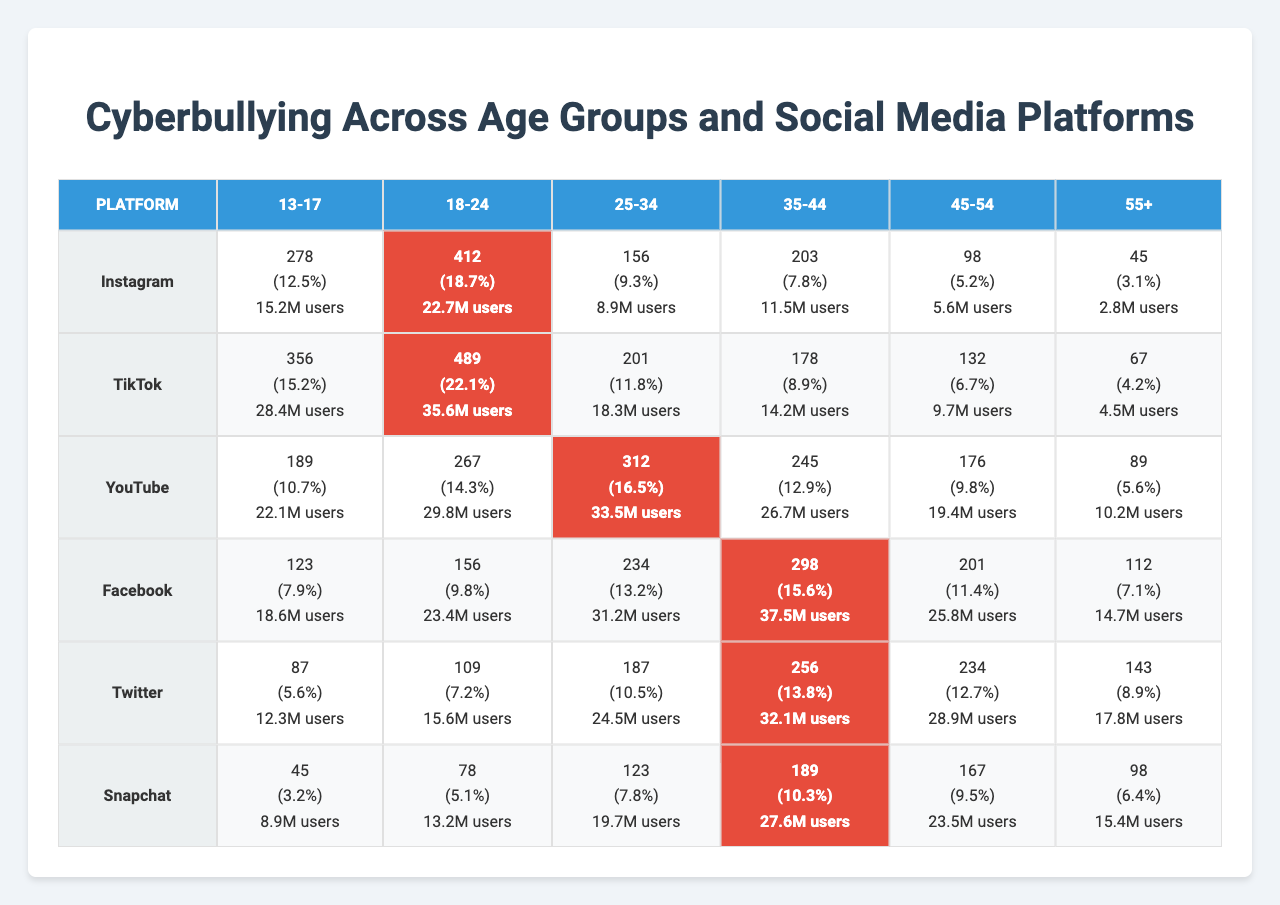What age group experiences the highest instances of cyberbullying on Instagram? By examining the table, we can see that the age group 18-24 has the highest number of cyberbullying instances on Instagram, with a total of 412.
Answer: 18-24 What is the total number of cyberbullying instances reported for the age group 35-44 across all platforms? To find this, we add the instances from the age group 35-44 across the platforms: 203 (Instagram) + 178 (TikTok) + 245 (YouTube) + 298 (Facebook) + 201 (Twitter) + 189 (Snapchat) = 1314.
Answer: 1314 Is TikTok the platform with the highest percentage increase in cyberbullying instances among the 25-34 age group? Looking at the data, TikTok displays an increase of 11.8% for the 25-34 age group. A comparison shows that Instagram has a 10.7% increase, so TikTok does have a higher percentage increase than the other platforms for this age group.
Answer: Yes What is the average number of cyberbullying instances across all age groups for Facebook? To calculate this, we total the instances for Facebook across all age groups: 203 + 178 + 245 + 298 + 256 + 189 = 1369. We then divide by the number of age groups (6). So, 1369 / 6 = 228.17.
Answer: 228.17 Which age group has the lowest number of cyberbullying instances on Snapchat? Examining the data, the age group 55+ has the lowest instances on Snapchat at 98.
Answer: 55+ What percentage of users experience cyberbullying instances compared to the total users in the 13-17 age group on YouTube? The number of instances for the 13-17 age group on YouTube is 156, and the total users are 8.9 million. The percentage is calculated as (156 / 8.9M) * 100. This results in approximately 1.75%.
Answer: 1.75% What is the trend of cyberbullying instances from the age group 45-54 to 55+ on Twitter? For the 45-54 age group, there are 234 instances on Twitter, while for 55+, there are 167 instances. Because 234 is greater than 167, we observe a decline in cyberbullying instances from the 45-54 to the 55+ age group on Twitter.
Answer: Decline Which platform shows the highest increase in cyberbullying instances for the age group 18-24 compared to the previous year? The table shows TikTok with an increase of 22.1% for the age group 18-24, which is the highest percentage increase compared to other platforms in the same age group.
Answer: TikTok Is there a consistent trend of decreasing cyberbullying instances as age increases across all platforms? Reviewing the number of instances for each age group across all platforms indicates that the total instances often decline as the age group increases; for instance, comparing 13-17 to 55+ shows a clear decrease in multiple platforms. However, this trend does not hold for every platform consistently, so we conclude that it is often seen but not universal.
Answer: No 